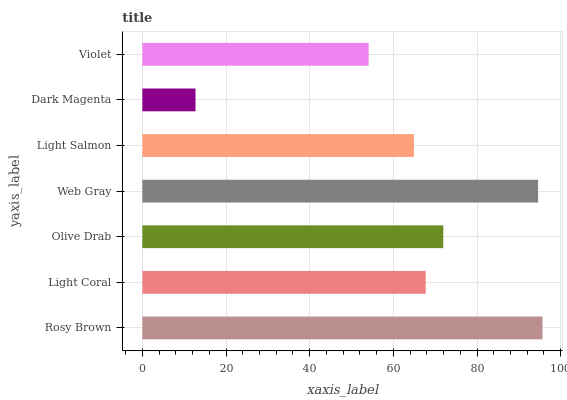Is Dark Magenta the minimum?
Answer yes or no. Yes. Is Rosy Brown the maximum?
Answer yes or no. Yes. Is Light Coral the minimum?
Answer yes or no. No. Is Light Coral the maximum?
Answer yes or no. No. Is Rosy Brown greater than Light Coral?
Answer yes or no. Yes. Is Light Coral less than Rosy Brown?
Answer yes or no. Yes. Is Light Coral greater than Rosy Brown?
Answer yes or no. No. Is Rosy Brown less than Light Coral?
Answer yes or no. No. Is Light Coral the high median?
Answer yes or no. Yes. Is Light Coral the low median?
Answer yes or no. Yes. Is Rosy Brown the high median?
Answer yes or no. No. Is Light Salmon the low median?
Answer yes or no. No. 